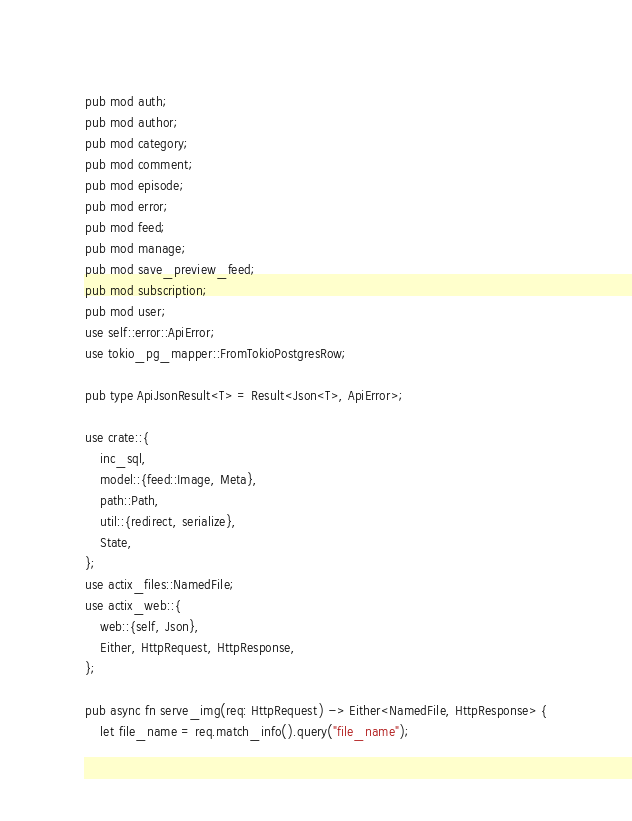Convert code to text. <code><loc_0><loc_0><loc_500><loc_500><_Rust_>pub mod auth;
pub mod author;
pub mod category;
pub mod comment;
pub mod episode;
pub mod error;
pub mod feed;
pub mod manage;
pub mod save_preview_feed;
pub mod subscription;
pub mod user;
use self::error::ApiError;
use tokio_pg_mapper::FromTokioPostgresRow;

pub type ApiJsonResult<T> = Result<Json<T>, ApiError>;

use crate::{
    inc_sql,
    model::{feed::Image, Meta},
    path::Path,
    util::{redirect, serialize},
    State,
};
use actix_files::NamedFile;
use actix_web::{
    web::{self, Json},
    Either, HttpRequest, HttpResponse,
};

pub async fn serve_img(req: HttpRequest) -> Either<NamedFile, HttpResponse> {
    let file_name = req.match_info().query("file_name");</code> 